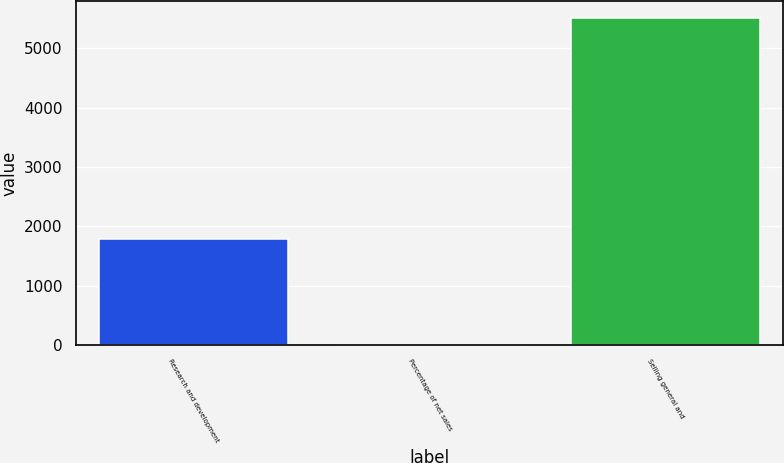Convert chart to OTSL. <chart><loc_0><loc_0><loc_500><loc_500><bar_chart><fcel>Research and development<fcel>Percentage of net sales<fcel>Selling general and<nl><fcel>1782<fcel>2.7<fcel>5517<nl></chart> 